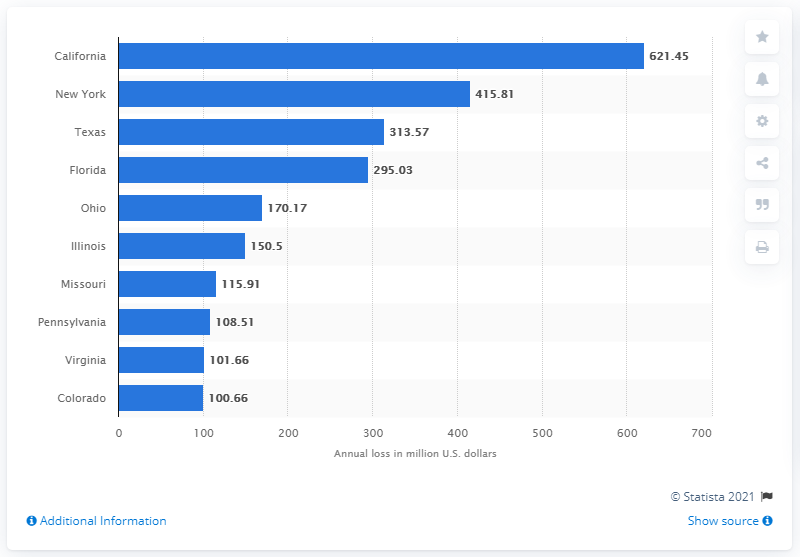Point out several critical features in this image. The amount of money lost by New York to the IC3 is $415.81. California lost approximately 621.45 million dollars due to cybercrime. 